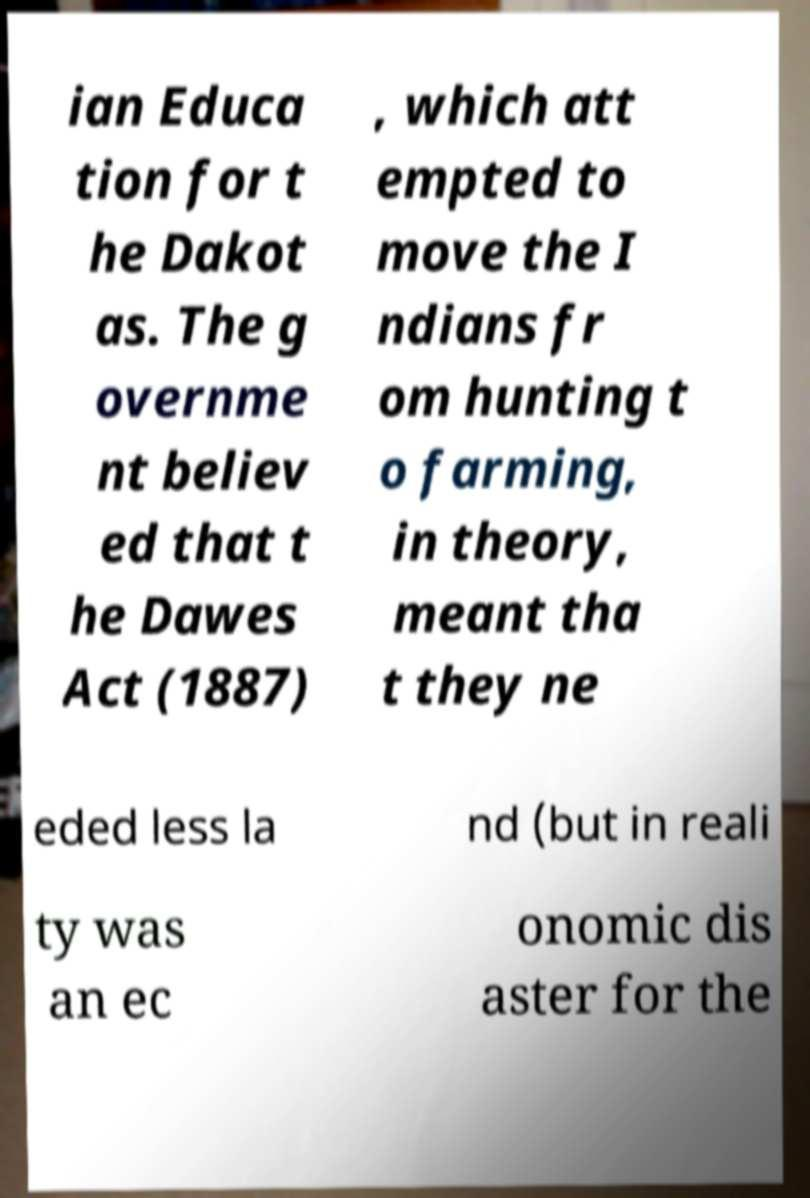What messages or text are displayed in this image? I need them in a readable, typed format. ian Educa tion for t he Dakot as. The g overnme nt believ ed that t he Dawes Act (1887) , which att empted to move the I ndians fr om hunting t o farming, in theory, meant tha t they ne eded less la nd (but in reali ty was an ec onomic dis aster for the 